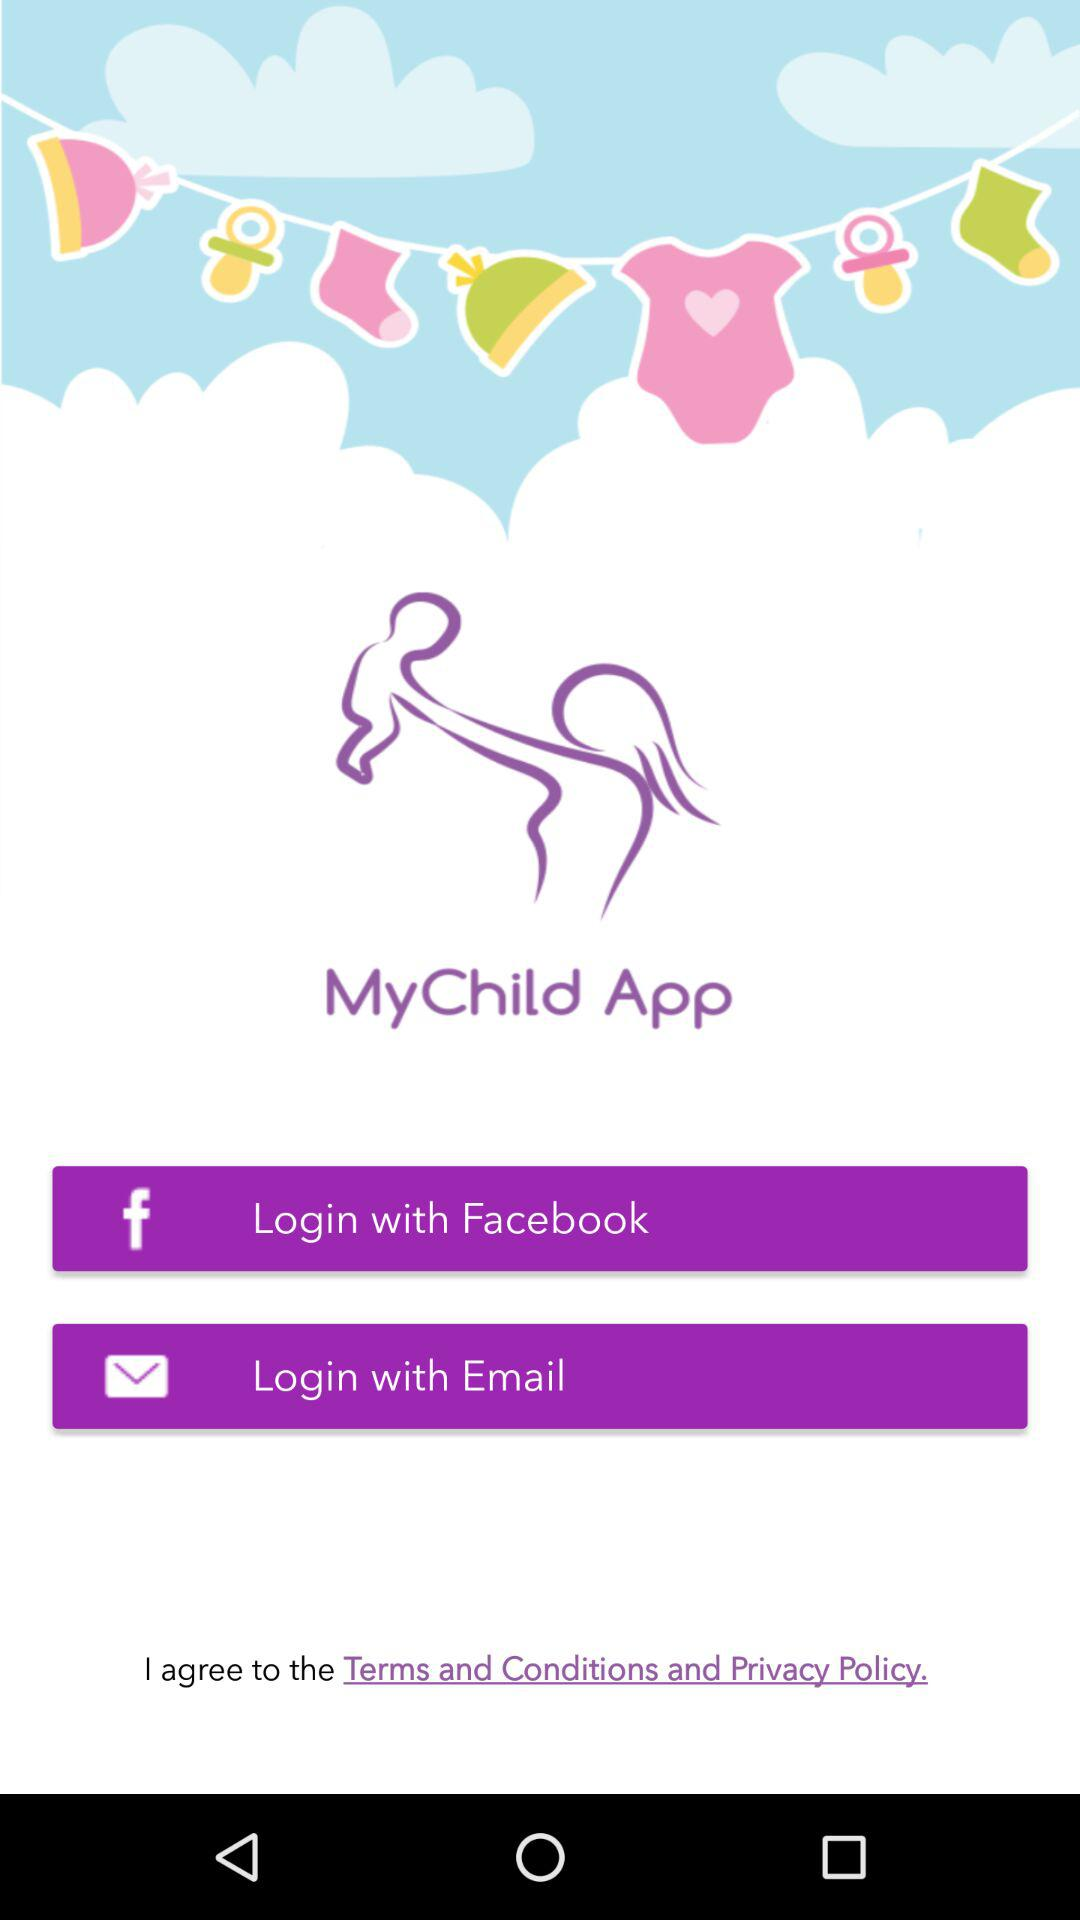What’s the app name? The app name is "MyChild". 